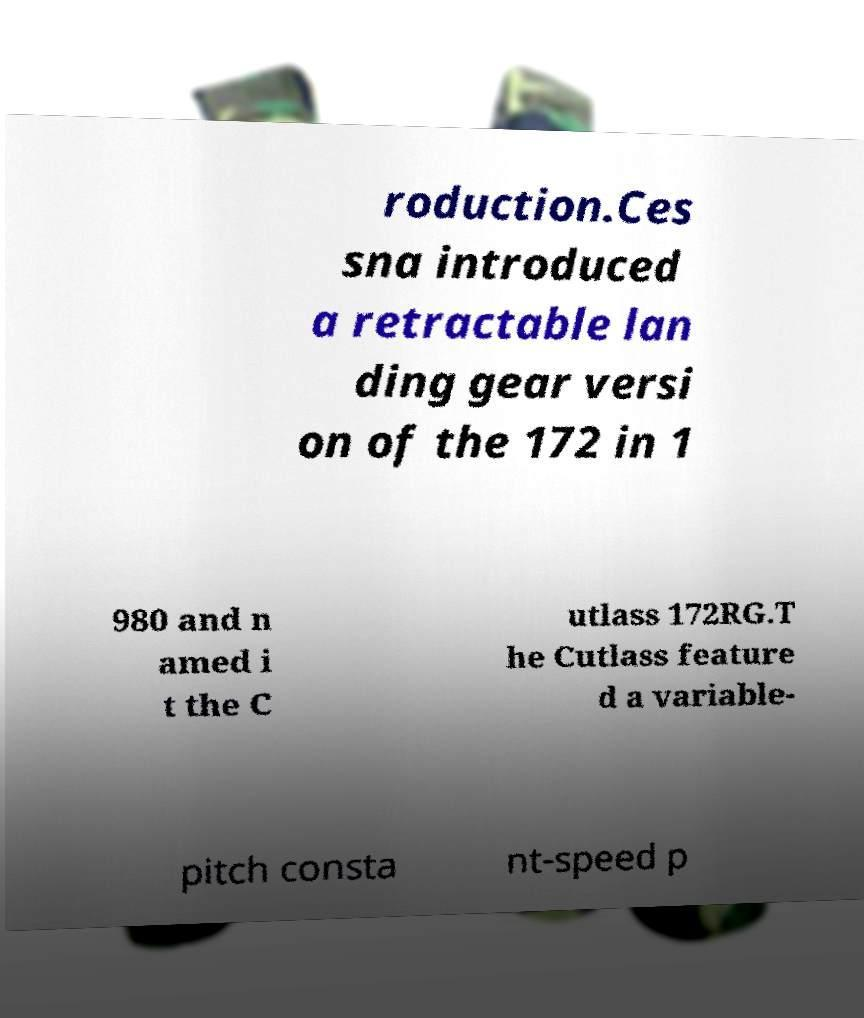For documentation purposes, I need the text within this image transcribed. Could you provide that? roduction.Ces sna introduced a retractable lan ding gear versi on of the 172 in 1 980 and n amed i t the C utlass 172RG.T he Cutlass feature d a variable- pitch consta nt-speed p 